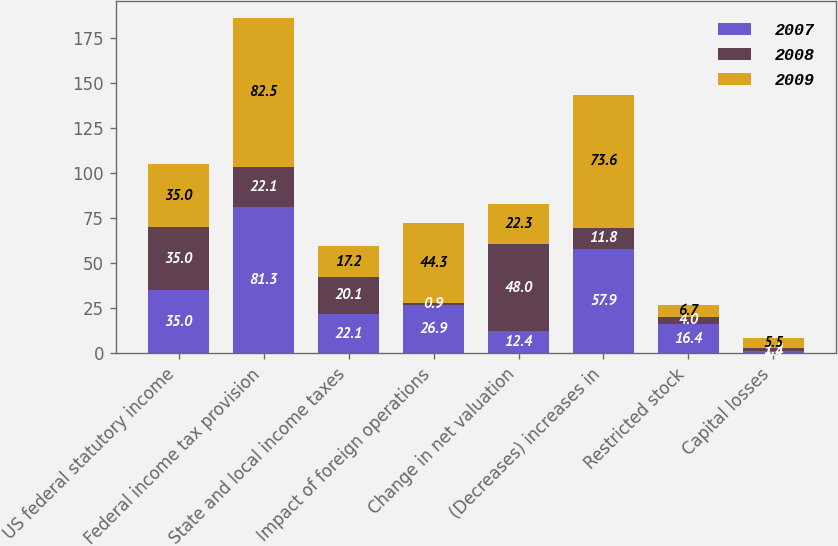Convert chart to OTSL. <chart><loc_0><loc_0><loc_500><loc_500><stacked_bar_chart><ecel><fcel>US federal statutory income<fcel>Federal income tax provision<fcel>State and local income taxes<fcel>Impact of foreign operations<fcel>Change in net valuation<fcel>(Decreases) increases in<fcel>Restricted stock<fcel>Capital losses<nl><fcel>2007<fcel>35<fcel>81.3<fcel>22.1<fcel>26.9<fcel>12.4<fcel>57.9<fcel>16.4<fcel>1.4<nl><fcel>2008<fcel>35<fcel>22.1<fcel>20.1<fcel>0.9<fcel>48<fcel>11.8<fcel>4<fcel>1.5<nl><fcel>2009<fcel>35<fcel>82.5<fcel>17.2<fcel>44.3<fcel>22.3<fcel>73.6<fcel>6.7<fcel>5.5<nl></chart> 